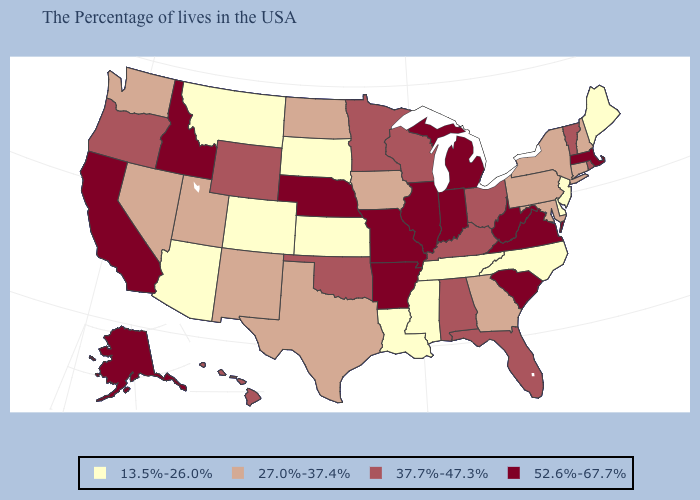Which states have the lowest value in the USA?
Quick response, please. Maine, New Jersey, Delaware, North Carolina, Tennessee, Mississippi, Louisiana, Kansas, South Dakota, Colorado, Montana, Arizona. Name the states that have a value in the range 13.5%-26.0%?
Keep it brief. Maine, New Jersey, Delaware, North Carolina, Tennessee, Mississippi, Louisiana, Kansas, South Dakota, Colorado, Montana, Arizona. Does Massachusetts have the same value as California?
Short answer required. Yes. Name the states that have a value in the range 13.5%-26.0%?
Concise answer only. Maine, New Jersey, Delaware, North Carolina, Tennessee, Mississippi, Louisiana, Kansas, South Dakota, Colorado, Montana, Arizona. Which states hav the highest value in the MidWest?
Keep it brief. Michigan, Indiana, Illinois, Missouri, Nebraska. Which states have the lowest value in the MidWest?
Short answer required. Kansas, South Dakota. Does South Dakota have a lower value than New Hampshire?
Give a very brief answer. Yes. Name the states that have a value in the range 13.5%-26.0%?
Quick response, please. Maine, New Jersey, Delaware, North Carolina, Tennessee, Mississippi, Louisiana, Kansas, South Dakota, Colorado, Montana, Arizona. Does Florida have a higher value than Tennessee?
Give a very brief answer. Yes. Name the states that have a value in the range 37.7%-47.3%?
Answer briefly. Rhode Island, Vermont, Ohio, Florida, Kentucky, Alabama, Wisconsin, Minnesota, Oklahoma, Wyoming, Oregon, Hawaii. Among the states that border Utah , does Colorado have the lowest value?
Concise answer only. Yes. Which states have the highest value in the USA?
Write a very short answer. Massachusetts, Virginia, South Carolina, West Virginia, Michigan, Indiana, Illinois, Missouri, Arkansas, Nebraska, Idaho, California, Alaska. Does Vermont have a higher value than Wisconsin?
Keep it brief. No. What is the value of North Dakota?
Quick response, please. 27.0%-37.4%. What is the highest value in states that border New Mexico?
Short answer required. 37.7%-47.3%. 